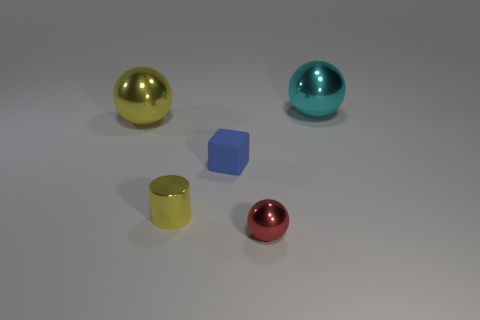Subtract all large cyan metallic spheres. How many spheres are left? 2 Subtract all red balls. How many balls are left? 2 Add 2 tiny things. How many objects exist? 7 Subtract all cylinders. How many objects are left? 4 Subtract 1 balls. How many balls are left? 2 Subtract 0 red cylinders. How many objects are left? 5 Subtract all purple cubes. Subtract all brown balls. How many cubes are left? 1 Subtract all gray blocks. How many blue balls are left? 0 Subtract all tiny metallic cylinders. Subtract all red shiny spheres. How many objects are left? 3 Add 2 yellow cylinders. How many yellow cylinders are left? 3 